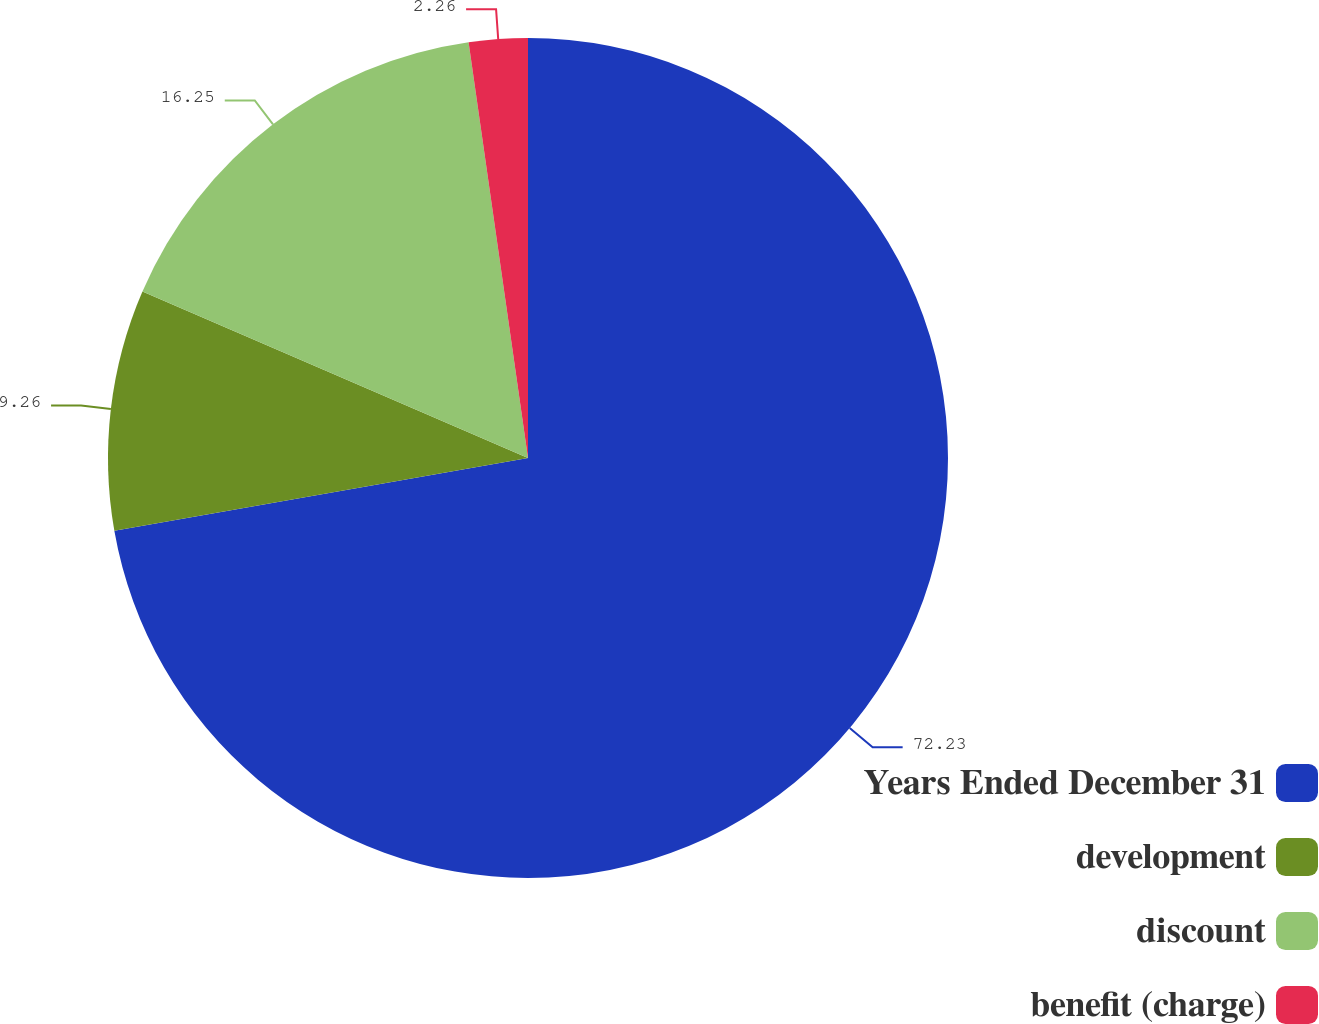Convert chart to OTSL. <chart><loc_0><loc_0><loc_500><loc_500><pie_chart><fcel>Years Ended December 31<fcel>development<fcel>discount<fcel>benefit (charge)<nl><fcel>72.23%<fcel>9.26%<fcel>16.25%<fcel>2.26%<nl></chart> 